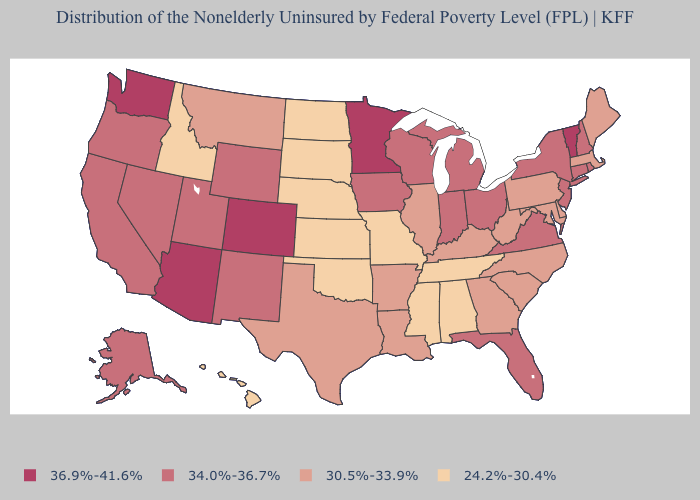Is the legend a continuous bar?
Give a very brief answer. No. Name the states that have a value in the range 24.2%-30.4%?
Keep it brief. Alabama, Hawaii, Idaho, Kansas, Mississippi, Missouri, Nebraska, North Dakota, Oklahoma, South Dakota, Tennessee. Among the states that border Connecticut , which have the highest value?
Answer briefly. New York, Rhode Island. Does the map have missing data?
Short answer required. No. Name the states that have a value in the range 34.0%-36.7%?
Give a very brief answer. Alaska, California, Connecticut, Florida, Indiana, Iowa, Michigan, Nevada, New Hampshire, New Jersey, New Mexico, New York, Ohio, Oregon, Rhode Island, Utah, Virginia, Wisconsin, Wyoming. What is the value of Tennessee?
Write a very short answer. 24.2%-30.4%. Does Delaware have the lowest value in the South?
Write a very short answer. No. Does Missouri have the lowest value in the USA?
Give a very brief answer. Yes. Name the states that have a value in the range 34.0%-36.7%?
Keep it brief. Alaska, California, Connecticut, Florida, Indiana, Iowa, Michigan, Nevada, New Hampshire, New Jersey, New Mexico, New York, Ohio, Oregon, Rhode Island, Utah, Virginia, Wisconsin, Wyoming. What is the highest value in the MidWest ?
Short answer required. 36.9%-41.6%. Does the first symbol in the legend represent the smallest category?
Keep it brief. No. What is the highest value in the South ?
Concise answer only. 34.0%-36.7%. What is the value of California?
Write a very short answer. 34.0%-36.7%. Does North Dakota have the lowest value in the USA?
Write a very short answer. Yes. Name the states that have a value in the range 36.9%-41.6%?
Give a very brief answer. Arizona, Colorado, Minnesota, Vermont, Washington. 